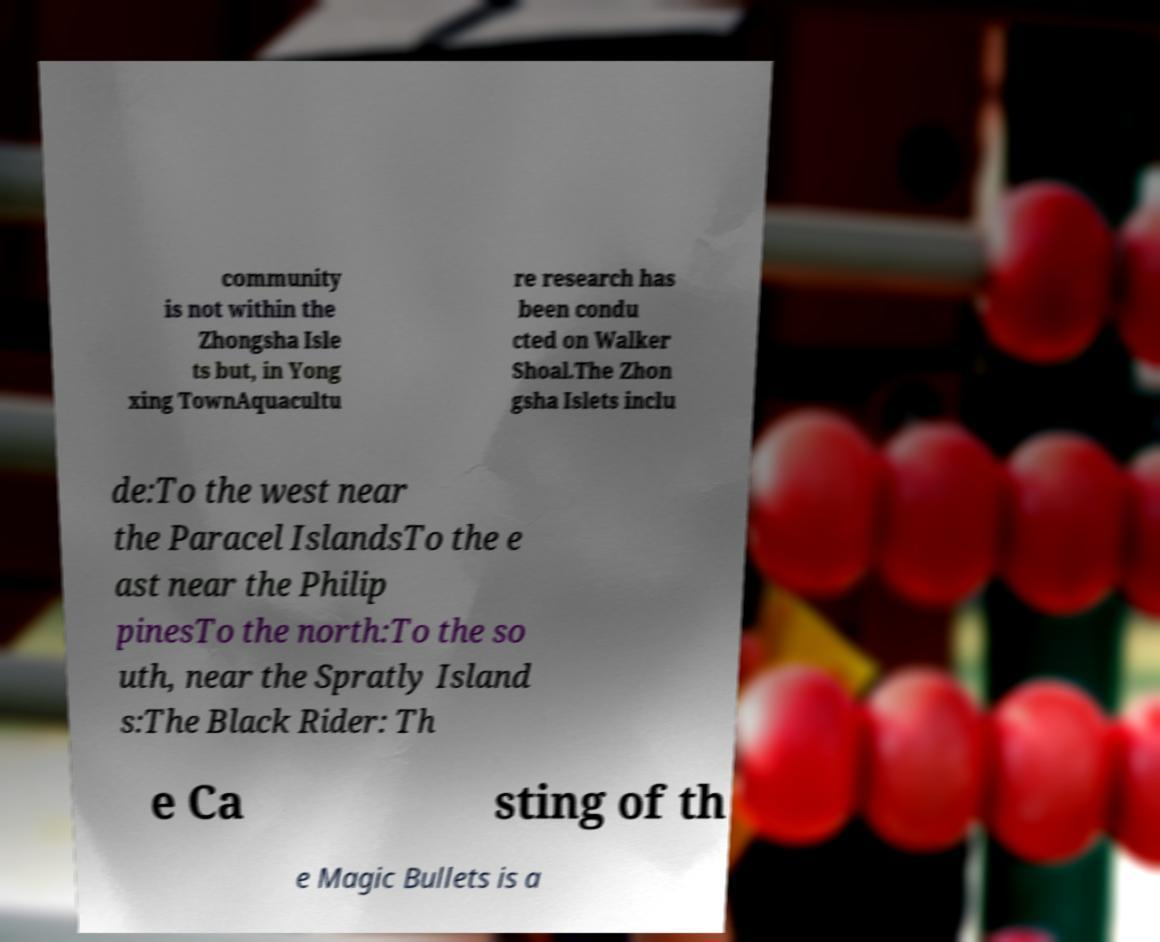Could you assist in decoding the text presented in this image and type it out clearly? community is not within the Zhongsha Isle ts but, in Yong xing TownAquacultu re research has been condu cted on Walker Shoal.The Zhon gsha Islets inclu de:To the west near the Paracel IslandsTo the e ast near the Philip pinesTo the north:To the so uth, near the Spratly Island s:The Black Rider: Th e Ca sting of th e Magic Bullets is a 